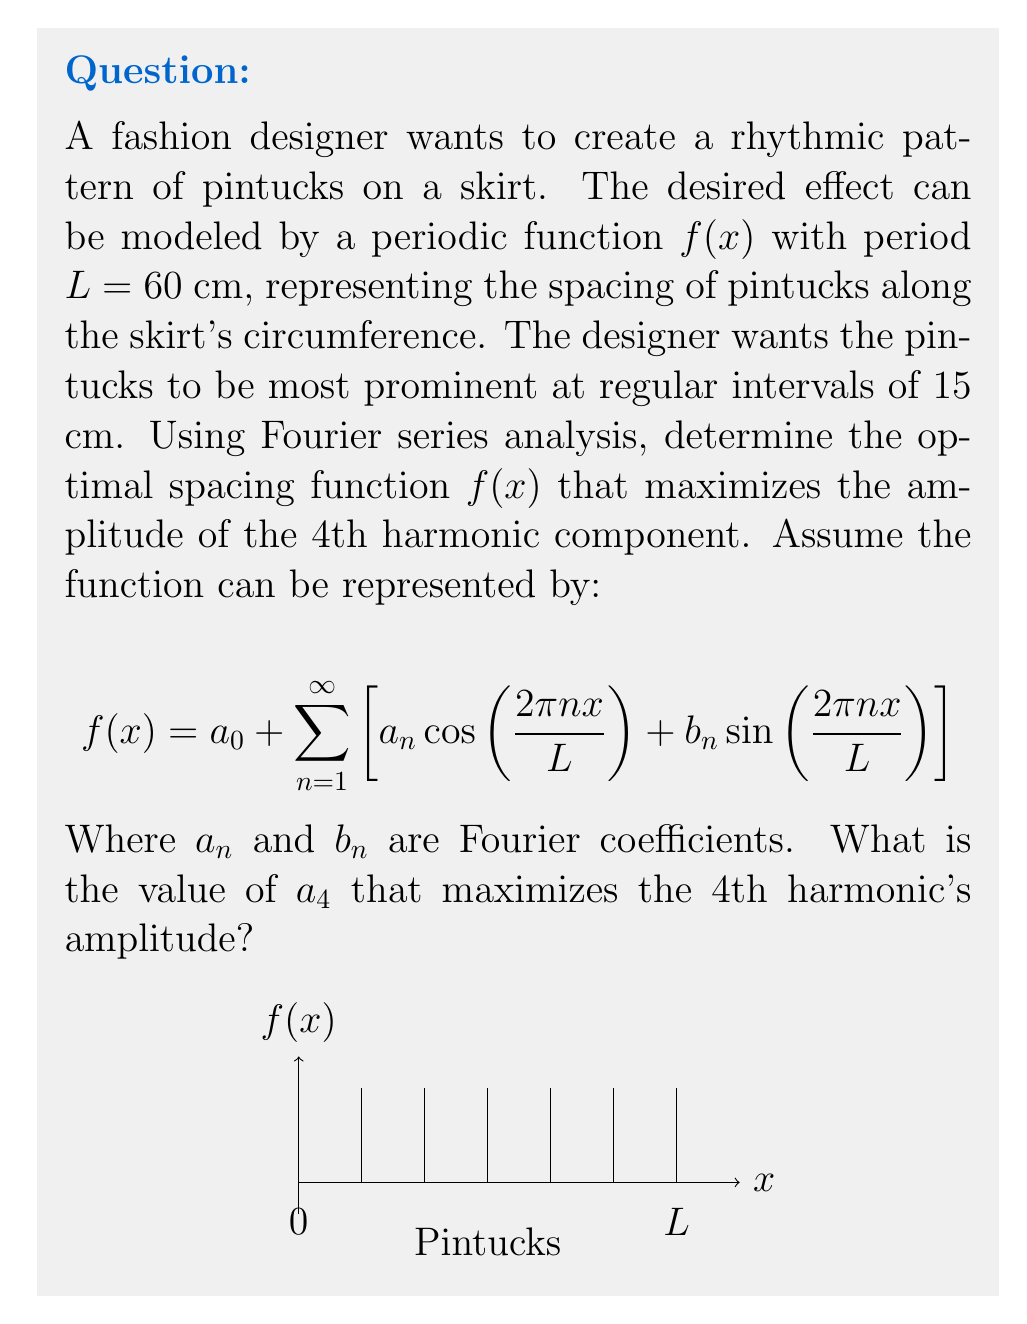Teach me how to tackle this problem. Let's approach this step-by-step:

1) The period $L = 60$ cm, and we want to maximize the 4th harmonic. This means we need to focus on the term with $n=4$ in the Fourier series.

2) The 4th harmonic component is represented by:

   $$a_4 \cos(\frac{2\pi 4x}{L}) + b_4 \sin(\frac{2\pi 4x}{L})$$

3) The amplitude of this harmonic is given by $\sqrt{a_4^2 + b_4^2}$.

4) To maximize the amplitude of the 4th harmonic, we need to maximize $a_4$ and set $b_4 = 0$. This is because cosine functions have maximum amplitude at $x=0$, which aligns with our desire for prominent pintucks at regular intervals.

5) The Fourier coefficient $a_4$ is calculated by:

   $$a_4 = \frac{2}{L} \int_0^L f(x) \cos(\frac{2\pi 4x}{L}) dx$$

6) To maximize this integral, $f(x)$ should be perfectly in phase with $\cos(\frac{2\pi 4x}{L})$. This means $f(x)$ should be:

   $$f(x) = A \cos(\frac{2\pi 4x}{L})$$

   where $A$ is the maximum amplitude.

7) Substituting this back into the integral:

   $$a_4 = \frac{2}{L} \int_0^L A \cos^2(\frac{2\pi 4x}{L}) dx = A$$

8) Therefore, the maximum value of $a_4$ is equal to the maximum amplitude $A$ of the function.

9) In clothing design, pintucks are typically small folds, so a reasonable maximum amplitude might be 0.5 cm.
Answer: $a_4 = 0.5$ cm 